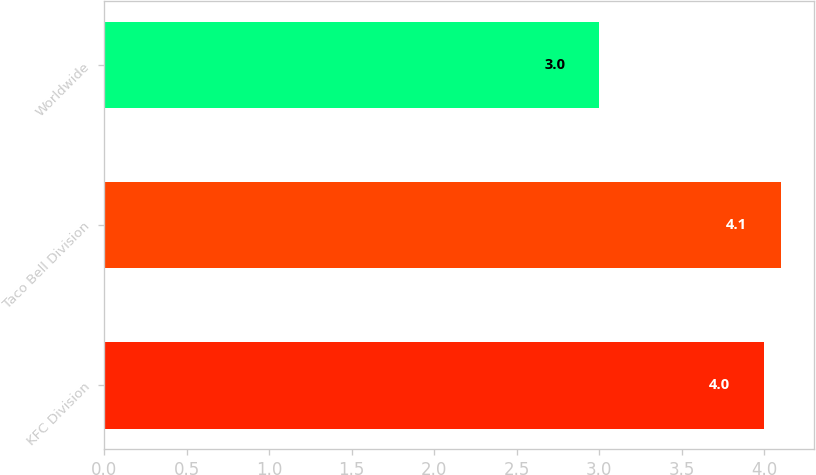Convert chart. <chart><loc_0><loc_0><loc_500><loc_500><bar_chart><fcel>KFC Division<fcel>Taco Bell Division<fcel>Worldwide<nl><fcel>4<fcel>4.1<fcel>3<nl></chart> 